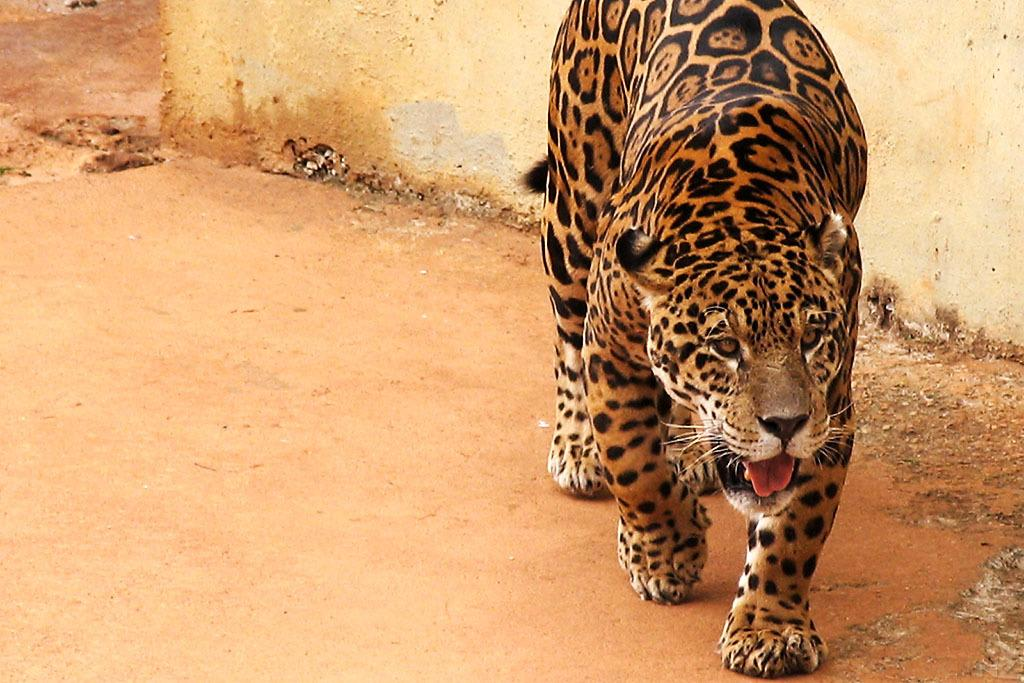What animal is in the image? There is a tiger in the image. What can be seen in the background of the image? There is a wall in the background of the image. Where can the ball be found in the image? There is no ball present in the image. What type of books are on the shelf in the image? There is no shelf or books present in the image. 